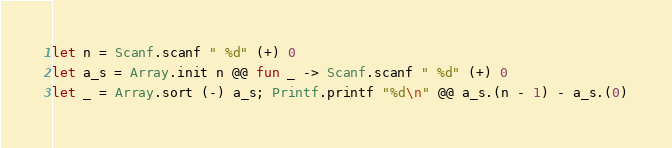Convert code to text. <code><loc_0><loc_0><loc_500><loc_500><_OCaml_>let n = Scanf.scanf " %d" (+) 0
let a_s = Array.init n @@ fun _ -> Scanf.scanf " %d" (+) 0
let _ = Array.sort (-) a_s; Printf.printf "%d\n" @@ a_s.(n - 1) - a_s.(0)</code> 